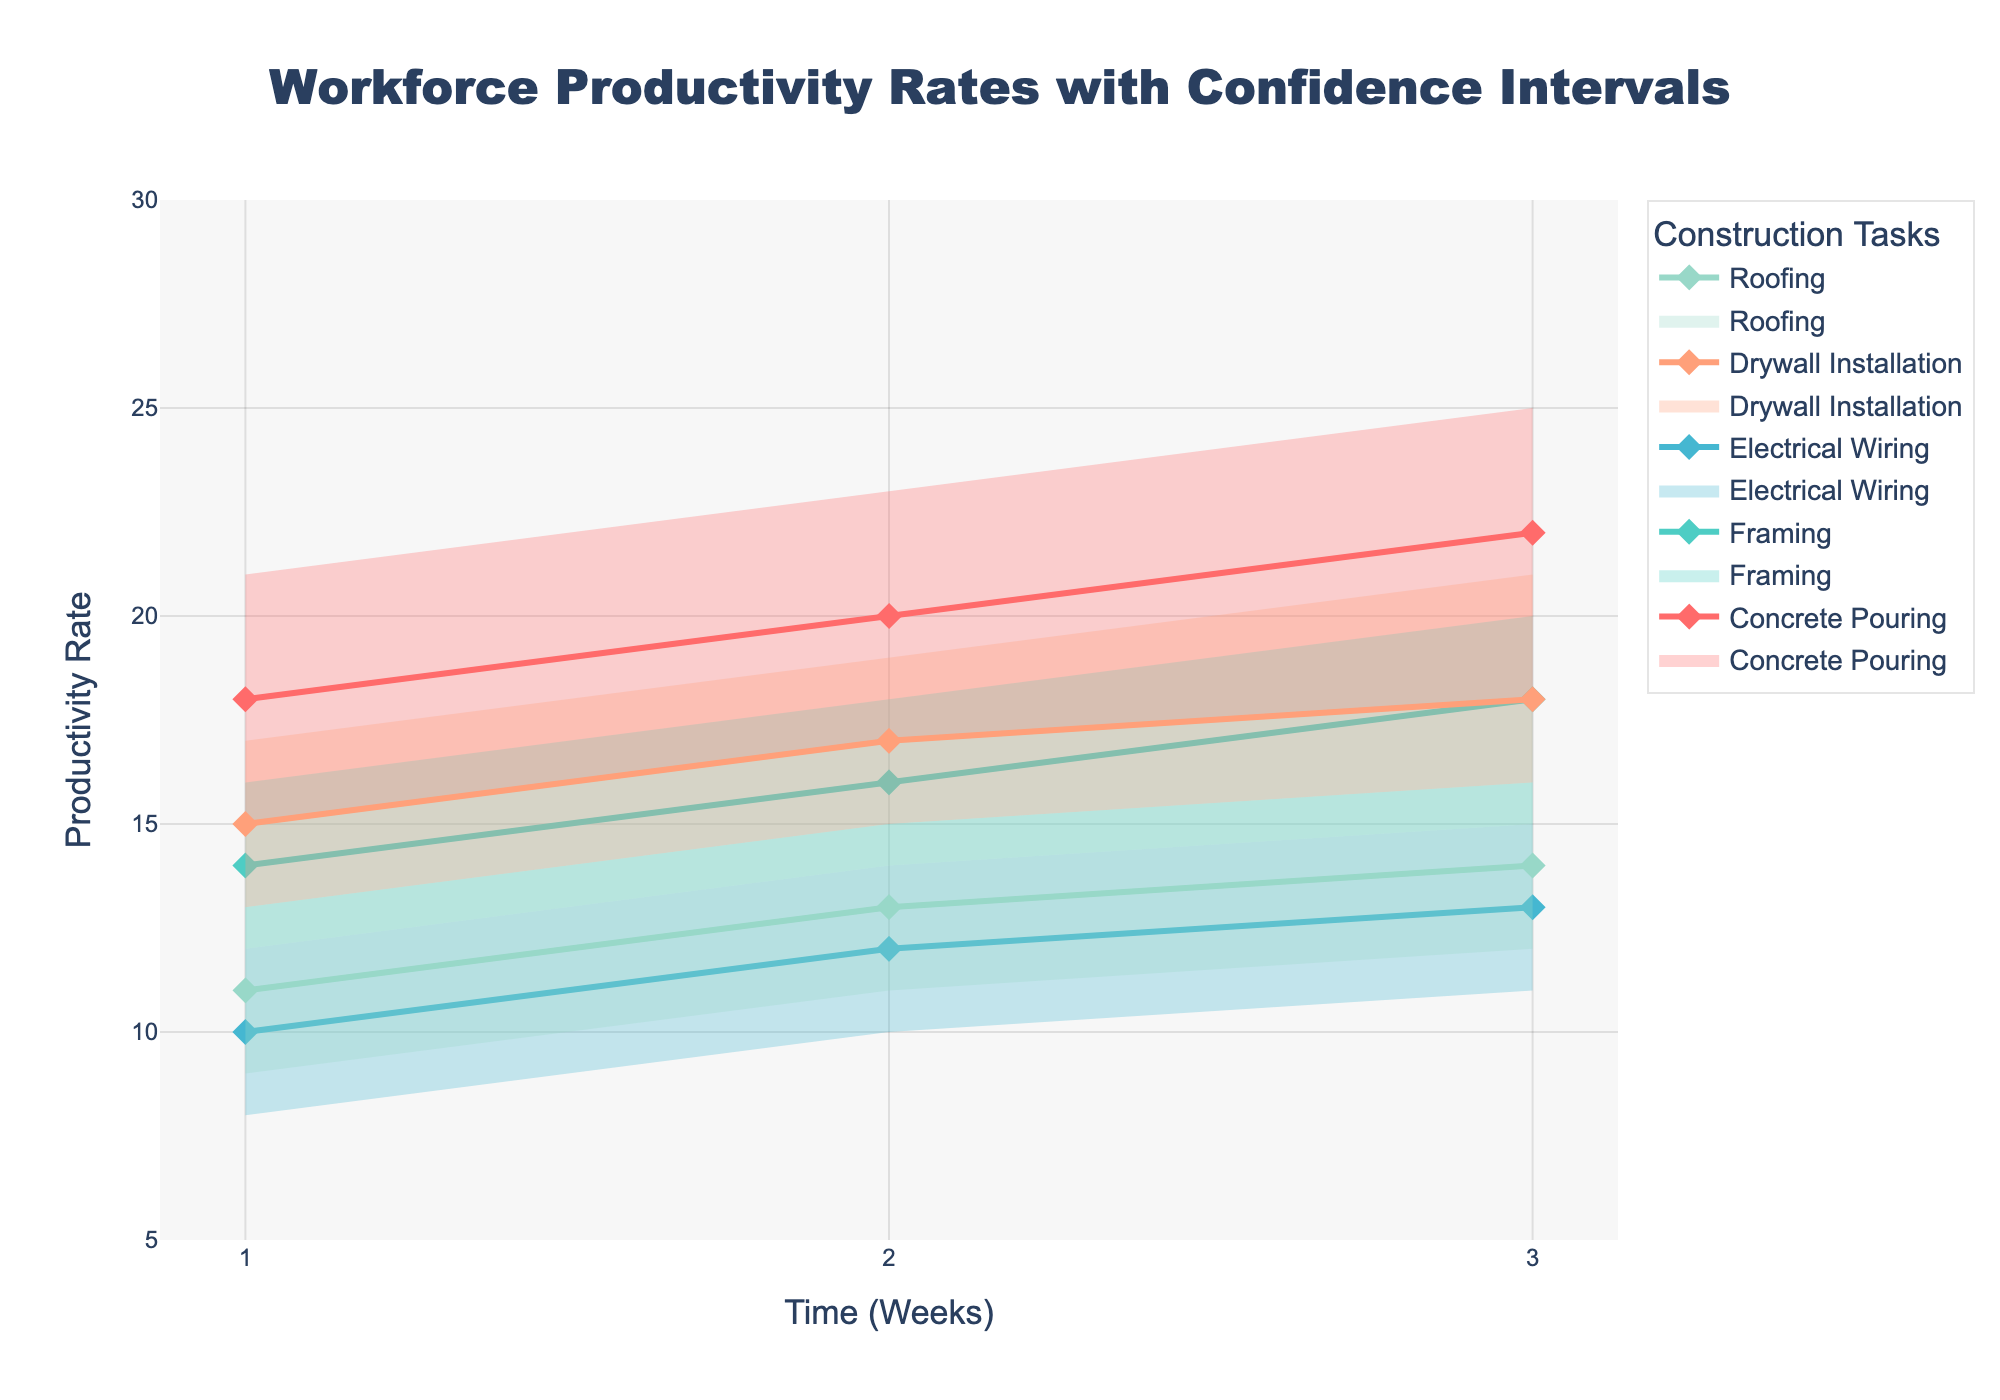What's the title of the chart? The title is typically found at the top of the chart and describes the primary focus of the visualization.
Answer: Workforce Productivity Rates with Confidence Intervals What is the x-axis representing? The x-axis usually identifies the independent variable being measured, which in this case is the "Time (Weeks)" as noted beneath the axis.
Answer: Time (Weeks) How many weeks of data are displayed for each task? By examining the x-axis and the lines of the fan chart, you can observe that each task is represented across 3 weeks.
Answer: 3 weeks Which construction task has the highest median productivity rate in week 1? To determine this, look at the median lines for all tasks at week 1 and find the one with the highest value. For week 1, the median values are as follows: Concrete Pouring (18), Framing (14), Electrical Wiring (10), Drywall Installation (15), and Roofing (11). Concrete Pouring has the highest at 18.
Answer: Concrete Pouring For Concrete Pouring, how much does the median productivity rate increase from week 1 to week 3? Identify the median values for Concrete Pouring at week 1 (18) and week 3 (22), then compute the difference: 22 - 18.
Answer: 4 Compare the confidence intervals for Framing and Drywall Installation in week 2. Which task has a higher variability? Compute the difference between the high and low confidence intervals for each task in week 2: Framing (18 - 14 = 4), Drywall Installation (19 - 15 = 4). Both tasks have the same variability of 4 units.
Answer: Equal variability What is the average median productivity rate of Electrical Wiring across the 3 weeks? Determine the median values for Electrical Wiring over the 3 weeks (10, 12, 13), sum them (10 + 12 + 13 = 35), and divide by 3 to get the average.
Answer: 11.67 Which task shows the least change in median productivity rate from week 1 to week 3? Calculate the difference in median productivity rates from week 1 to week 3 for each task: Concrete Pouring (4), Framing (4), Electrical Wiring (3), Drywall Installation (3), Roofing (3). Electrical Wiring, Drywall Installation, and Roofing all show the least changes, which is 3.
Answer: Electrical Wiring, Drywall Installation, Roofing How does the productivity rate of Roofing compare between week 1 and week 2? Examine the median productivity rates for Roofing at week 1 (11) and week 2 (13), and compare them. There is an increase in productivity.
Answer: Increased Based on the fan chart, which task has the narrowest confidence interval in week 3? Examine the width of the confidence intervals for each task in week 3: Concrete Pouring (25 - 18 = 7), Framing (20 - 15 = 5), Electrical Wiring (15 - 11 = 4), Drywall Installation (21 - 16 = 5), Roofing (16 - 12 = 4). Electrical Wiring and Roofing both have the narrowest intervals of 4.
Answer: Electrical Wiring, Roofing 